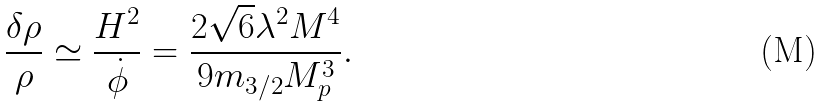Convert formula to latex. <formula><loc_0><loc_0><loc_500><loc_500>\frac { \delta \rho } { \rho } \simeq \frac { H ^ { 2 } } { \dot { \phi } } = \frac { 2 \sqrt { 6 } \lambda ^ { 2 } M ^ { 4 } } { 9 m _ { 3 / 2 } M _ { p } ^ { 3 } } .</formula> 